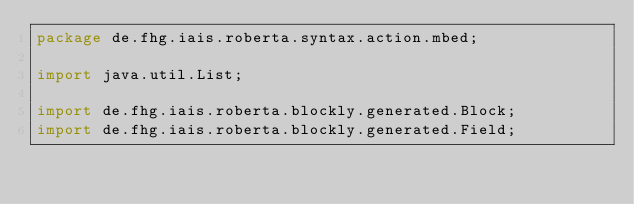Convert code to text. <code><loc_0><loc_0><loc_500><loc_500><_Java_>package de.fhg.iais.roberta.syntax.action.mbed;

import java.util.List;

import de.fhg.iais.roberta.blockly.generated.Block;
import de.fhg.iais.roberta.blockly.generated.Field;</code> 